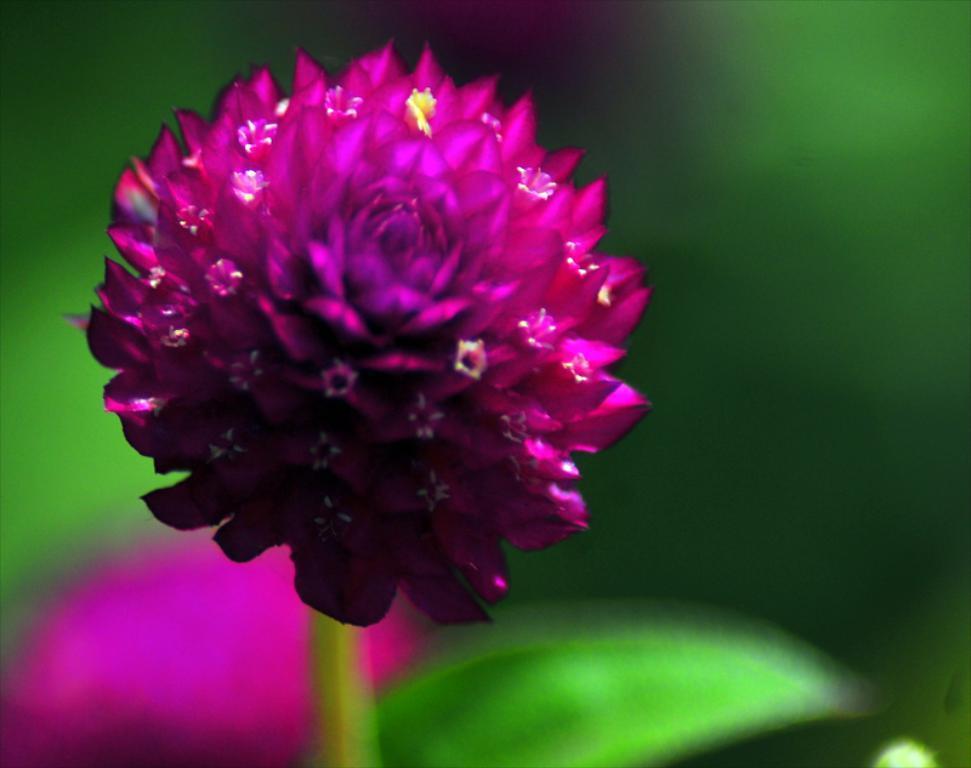Please provide a concise description of this image. Background portion of the picture is blur. We can see stem and leaf. In this picture we can see a flower. 